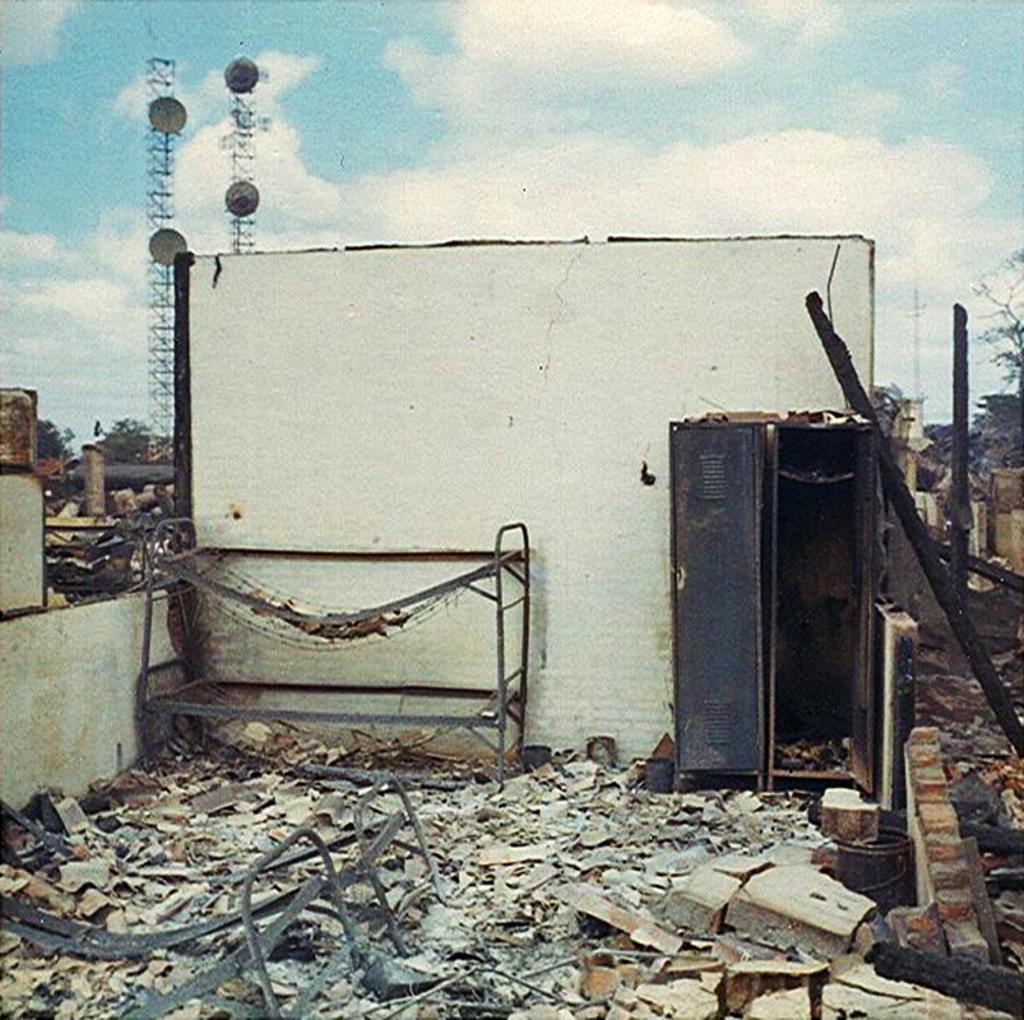Can you describe this image briefly? In this image I can see number of stones, few iron things, an almirah, a bucket and few other stuffs on the ground. In the background I can see white colour wall, few towers, few antennas, number of trees, clouds and the sky. 